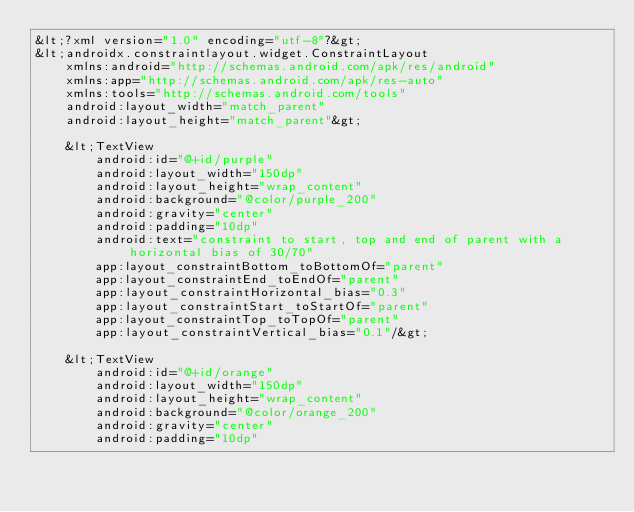<code> <loc_0><loc_0><loc_500><loc_500><_XML_>&lt;?xml version="1.0" encoding="utf-8"?&gt;
&lt;androidx.constraintlayout.widget.ConstraintLayout
    xmlns:android="http://schemas.android.com/apk/res/android"
    xmlns:app="http://schemas.android.com/apk/res-auto"
    xmlns:tools="http://schemas.android.com/tools"
    android:layout_width="match_parent"
    android:layout_height="match_parent"&gt;

    &lt;TextView
        android:id="@+id/purple"
        android:layout_width="150dp"
        android:layout_height="wrap_content"
        android:background="@color/purple_200"
        android:gravity="center"
        android:padding="10dp"
        android:text="constraint to start, top and end of parent with a horizontal bias of 30/70"
        app:layout_constraintBottom_toBottomOf="parent"
        app:layout_constraintEnd_toEndOf="parent"
        app:layout_constraintHorizontal_bias="0.3"
        app:layout_constraintStart_toStartOf="parent"
        app:layout_constraintTop_toTopOf="parent"
        app:layout_constraintVertical_bias="0.1"/&gt;

    &lt;TextView
        android:id="@+id/orange"
        android:layout_width="150dp"
        android:layout_height="wrap_content"
        android:background="@color/orange_200"
        android:gravity="center"
        android:padding="10dp"</code> 